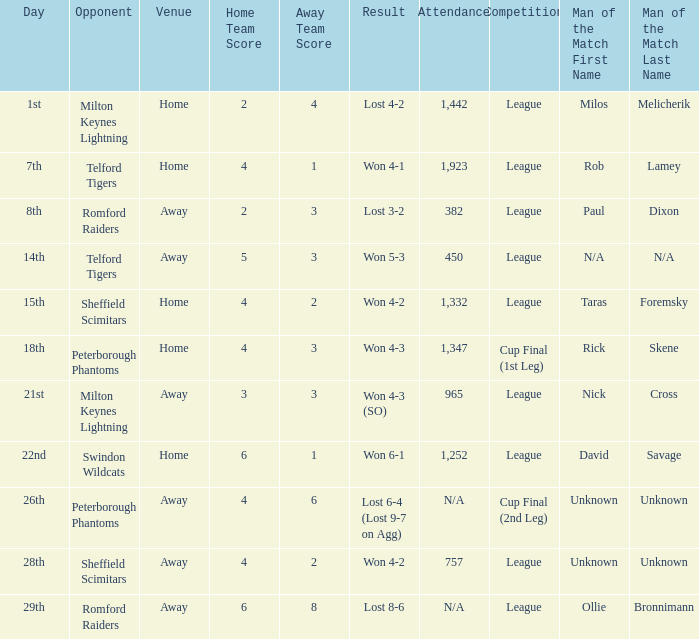What competition was held on the 26th? Cup Final (2nd Leg). 